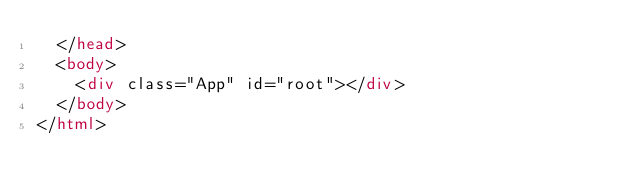<code> <loc_0><loc_0><loc_500><loc_500><_HTML_>  </head>
  <body>
    <div class="App" id="root"></div>
  </body>
</html>
</code> 